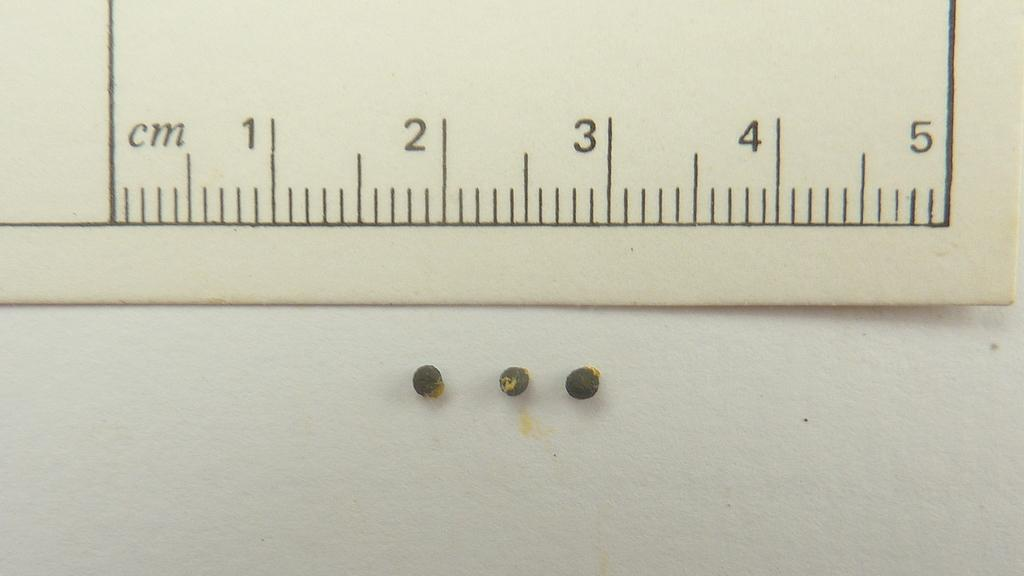What is located at the top of the image? There is a board at the top of the image. What can be found on the board? There are measurements on the board. What is in the center of the image? There are small balls in the center of the image. What can be seen in the background of the image? There is a wall in the background of the image. What flavor of shoe is depicted in the image? There is no shoe present in the image, so it is not possible to determine its flavor. 